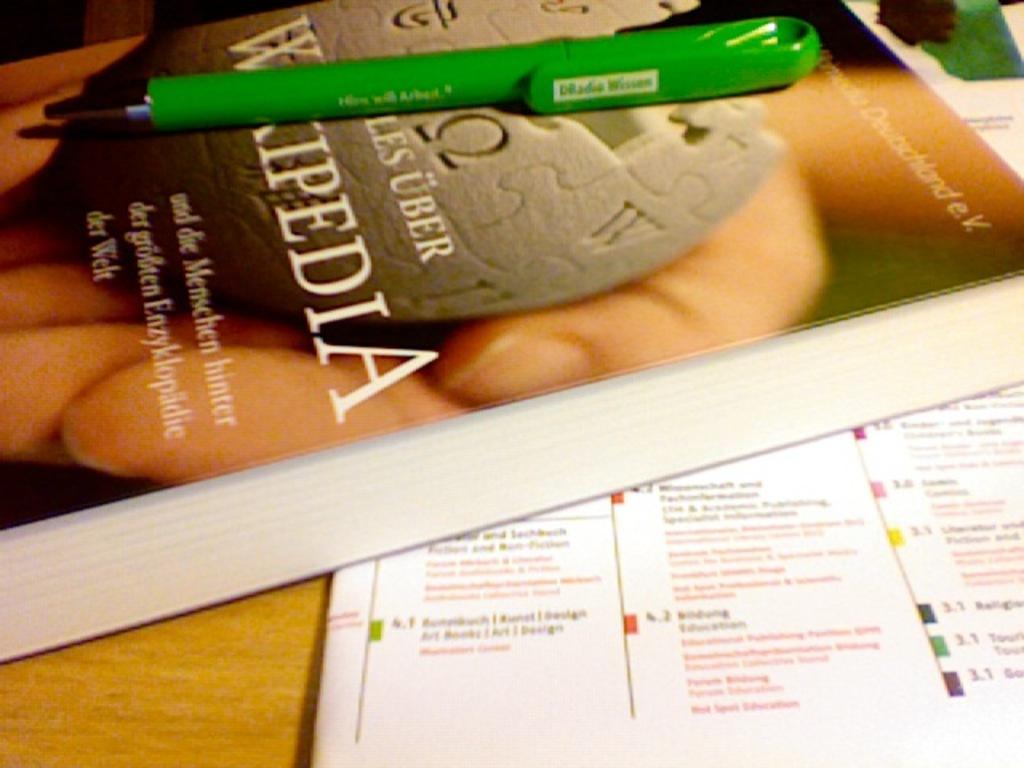What website is the book about?
Provide a succinct answer. Wikipedia. 